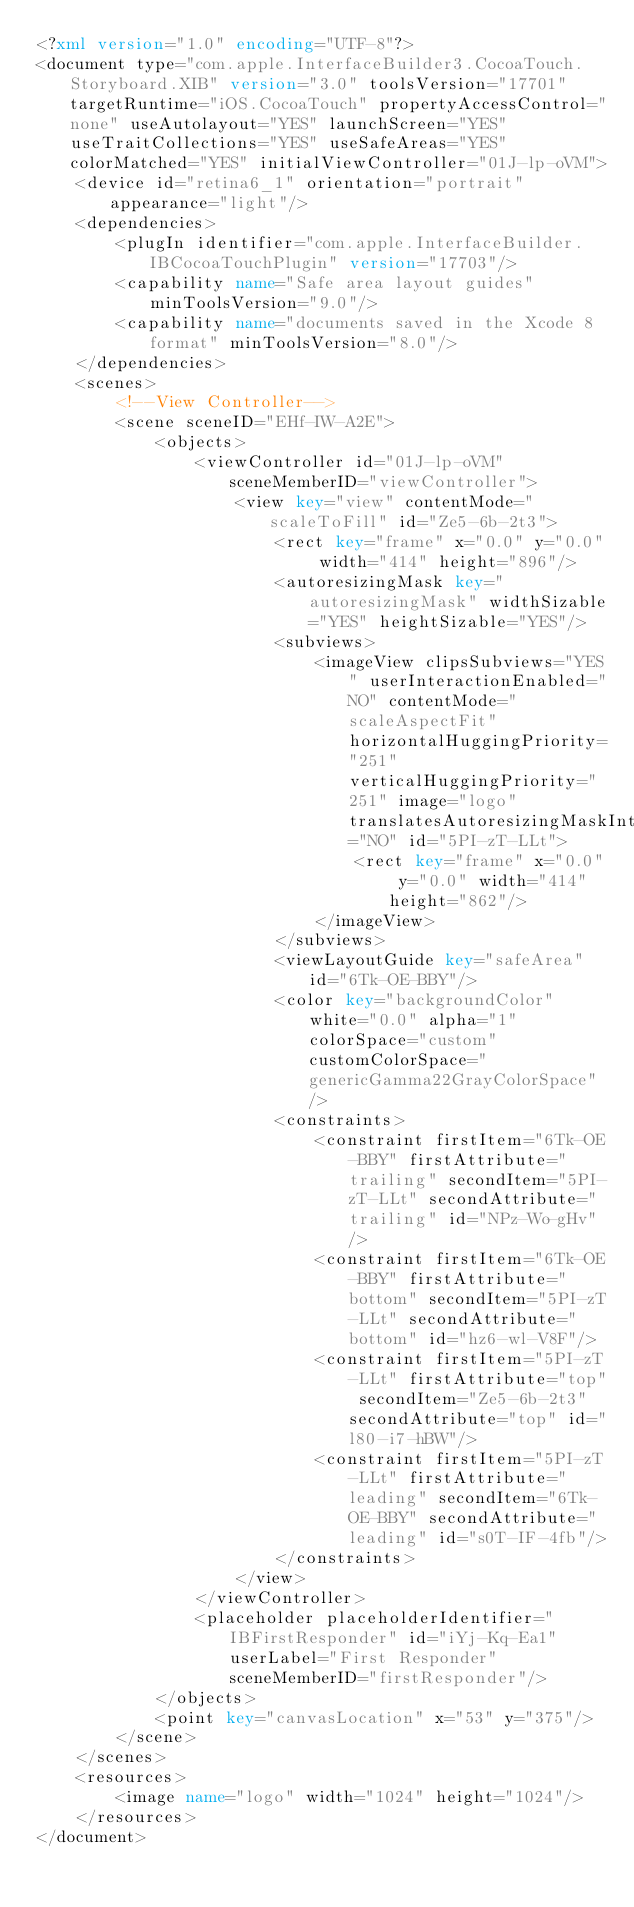Convert code to text. <code><loc_0><loc_0><loc_500><loc_500><_XML_><?xml version="1.0" encoding="UTF-8"?>
<document type="com.apple.InterfaceBuilder3.CocoaTouch.Storyboard.XIB" version="3.0" toolsVersion="17701" targetRuntime="iOS.CocoaTouch" propertyAccessControl="none" useAutolayout="YES" launchScreen="YES" useTraitCollections="YES" useSafeAreas="YES" colorMatched="YES" initialViewController="01J-lp-oVM">
    <device id="retina6_1" orientation="portrait" appearance="light"/>
    <dependencies>
        <plugIn identifier="com.apple.InterfaceBuilder.IBCocoaTouchPlugin" version="17703"/>
        <capability name="Safe area layout guides" minToolsVersion="9.0"/>
        <capability name="documents saved in the Xcode 8 format" minToolsVersion="8.0"/>
    </dependencies>
    <scenes>
        <!--View Controller-->
        <scene sceneID="EHf-IW-A2E">
            <objects>
                <viewController id="01J-lp-oVM" sceneMemberID="viewController">
                    <view key="view" contentMode="scaleToFill" id="Ze5-6b-2t3">
                        <rect key="frame" x="0.0" y="0.0" width="414" height="896"/>
                        <autoresizingMask key="autoresizingMask" widthSizable="YES" heightSizable="YES"/>
                        <subviews>
                            <imageView clipsSubviews="YES" userInteractionEnabled="NO" contentMode="scaleAspectFit" horizontalHuggingPriority="251" verticalHuggingPriority="251" image="logo" translatesAutoresizingMaskIntoConstraints="NO" id="5PI-zT-LLt">
                                <rect key="frame" x="0.0" y="0.0" width="414" height="862"/>
                            </imageView>
                        </subviews>
                        <viewLayoutGuide key="safeArea" id="6Tk-OE-BBY"/>
                        <color key="backgroundColor" white="0.0" alpha="1" colorSpace="custom" customColorSpace="genericGamma22GrayColorSpace"/>
                        <constraints>
                            <constraint firstItem="6Tk-OE-BBY" firstAttribute="trailing" secondItem="5PI-zT-LLt" secondAttribute="trailing" id="NPz-Wo-gHv"/>
                            <constraint firstItem="6Tk-OE-BBY" firstAttribute="bottom" secondItem="5PI-zT-LLt" secondAttribute="bottom" id="hz6-wl-V8F"/>
                            <constraint firstItem="5PI-zT-LLt" firstAttribute="top" secondItem="Ze5-6b-2t3" secondAttribute="top" id="l80-i7-hBW"/>
                            <constraint firstItem="5PI-zT-LLt" firstAttribute="leading" secondItem="6Tk-OE-BBY" secondAttribute="leading" id="s0T-IF-4fb"/>
                        </constraints>
                    </view>
                </viewController>
                <placeholder placeholderIdentifier="IBFirstResponder" id="iYj-Kq-Ea1" userLabel="First Responder" sceneMemberID="firstResponder"/>
            </objects>
            <point key="canvasLocation" x="53" y="375"/>
        </scene>
    </scenes>
    <resources>
        <image name="logo" width="1024" height="1024"/>
    </resources>
</document>
</code> 